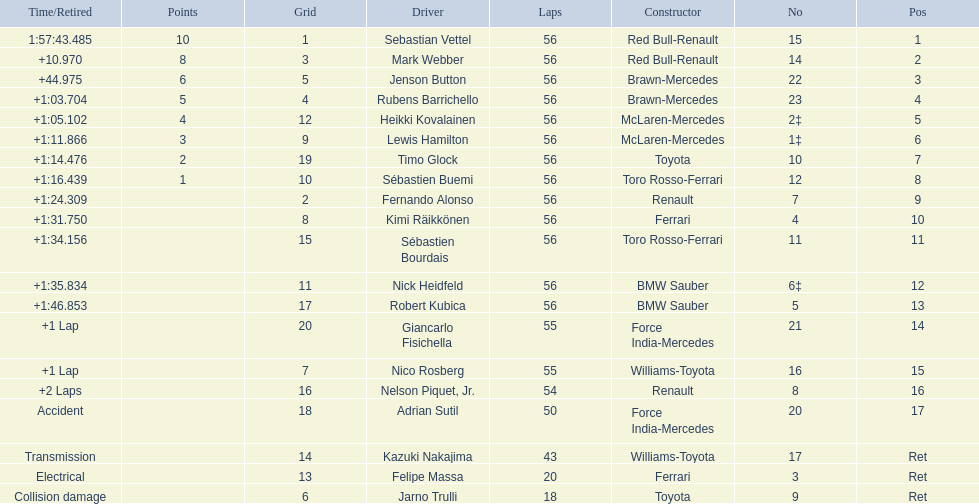Why did the  toyota retire Collision damage. What was the drivers name? Jarno Trulli. 